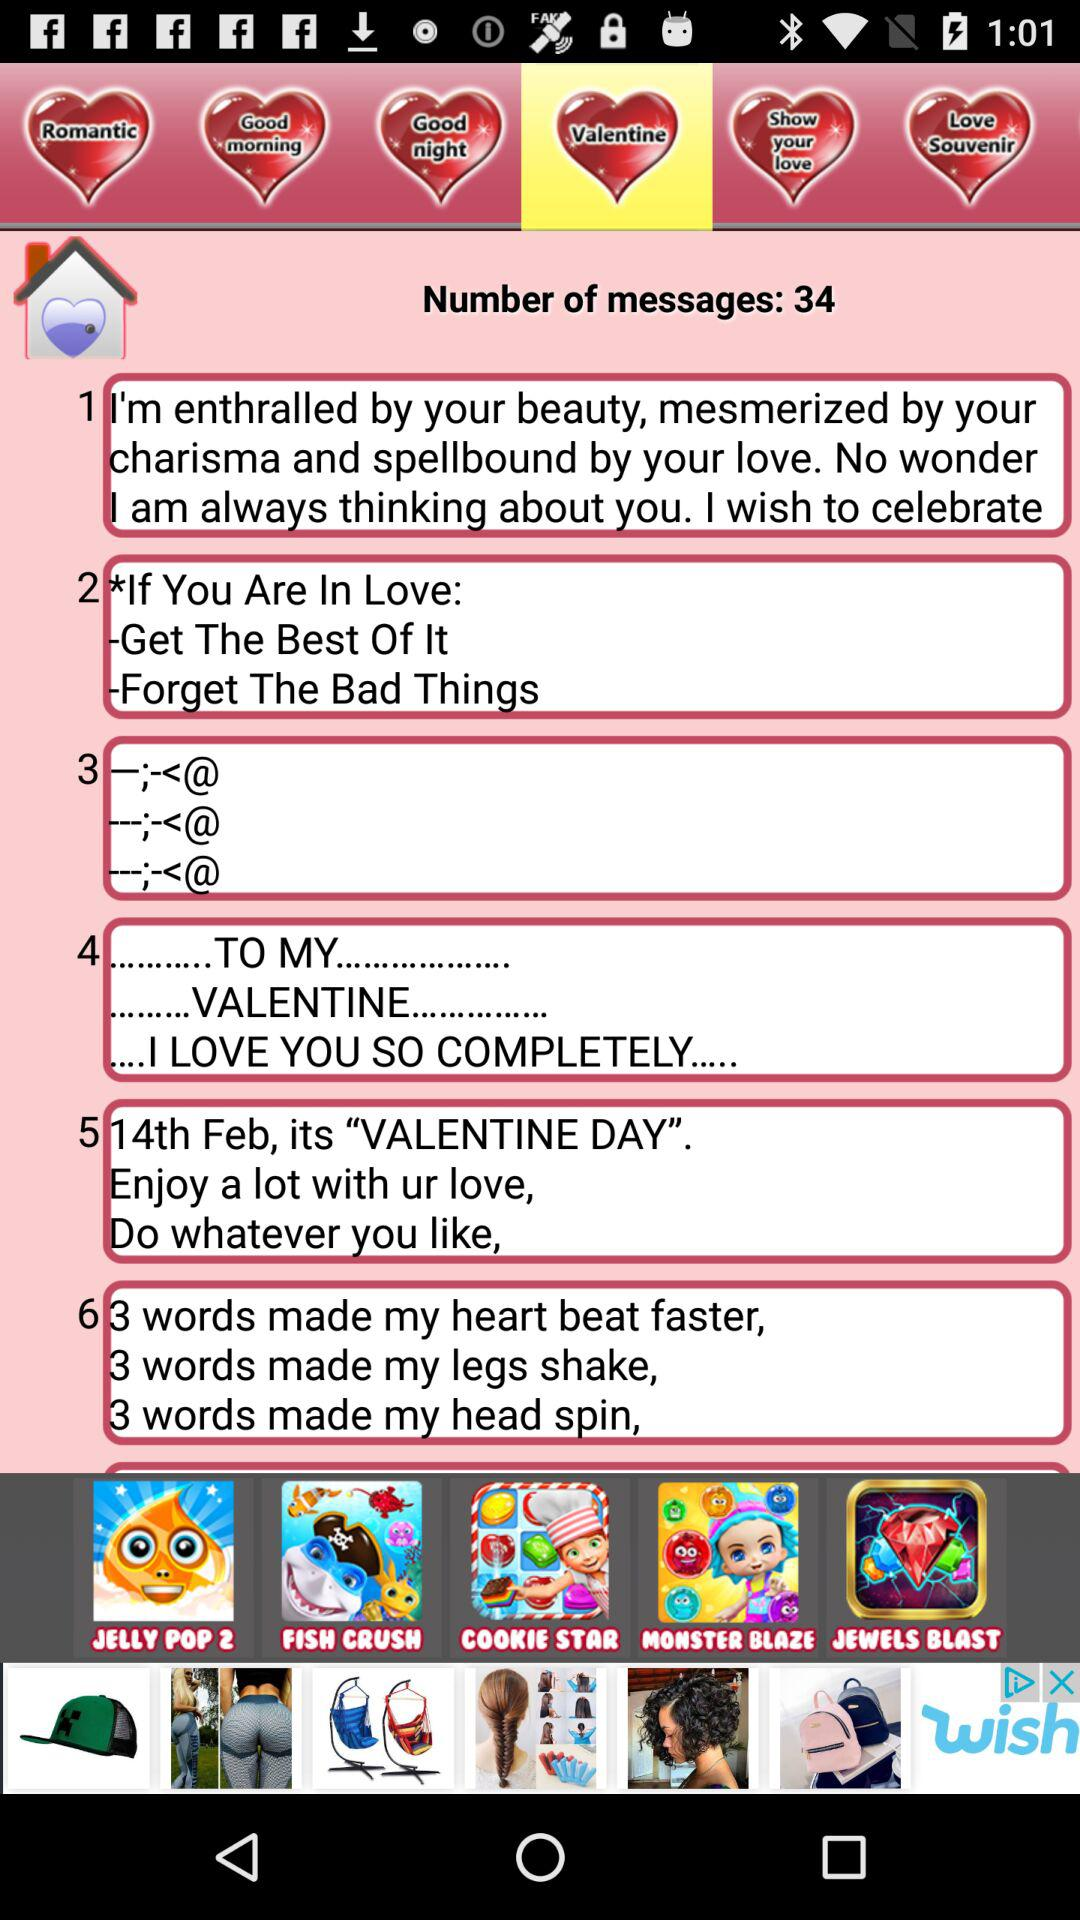What is the total number of messages? The total number of messages is 34. 